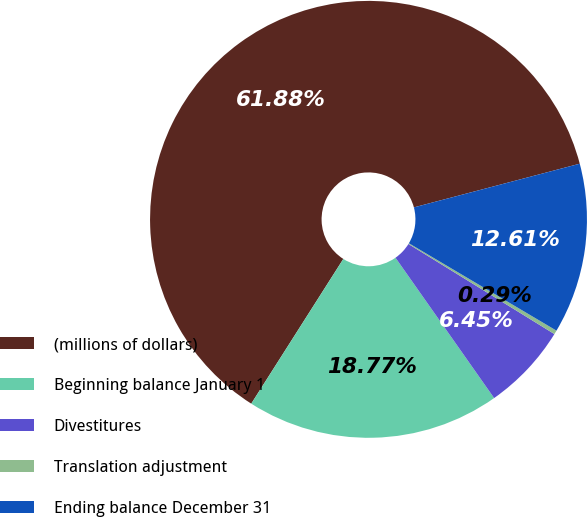<chart> <loc_0><loc_0><loc_500><loc_500><pie_chart><fcel>(millions of dollars)<fcel>Beginning balance January 1<fcel>Divestitures<fcel>Translation adjustment<fcel>Ending balance December 31<nl><fcel>61.89%<fcel>18.77%<fcel>6.45%<fcel>0.29%<fcel>12.61%<nl></chart> 